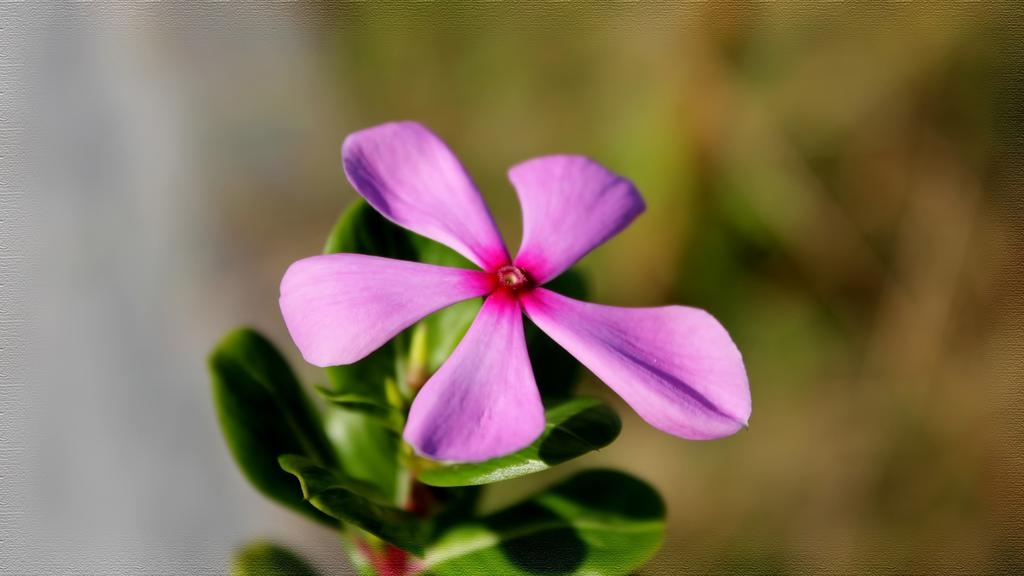What type of flower is in the image? There is a purple flower in the image. Where is the flower located? The flower is on a plant. Can you describe the background of the image? The background of the image is blurred. What type of clam can be seen cooking in the oven in the image? There is no clam or oven present in the image; it features a purple flower on a plant with a blurred background. 